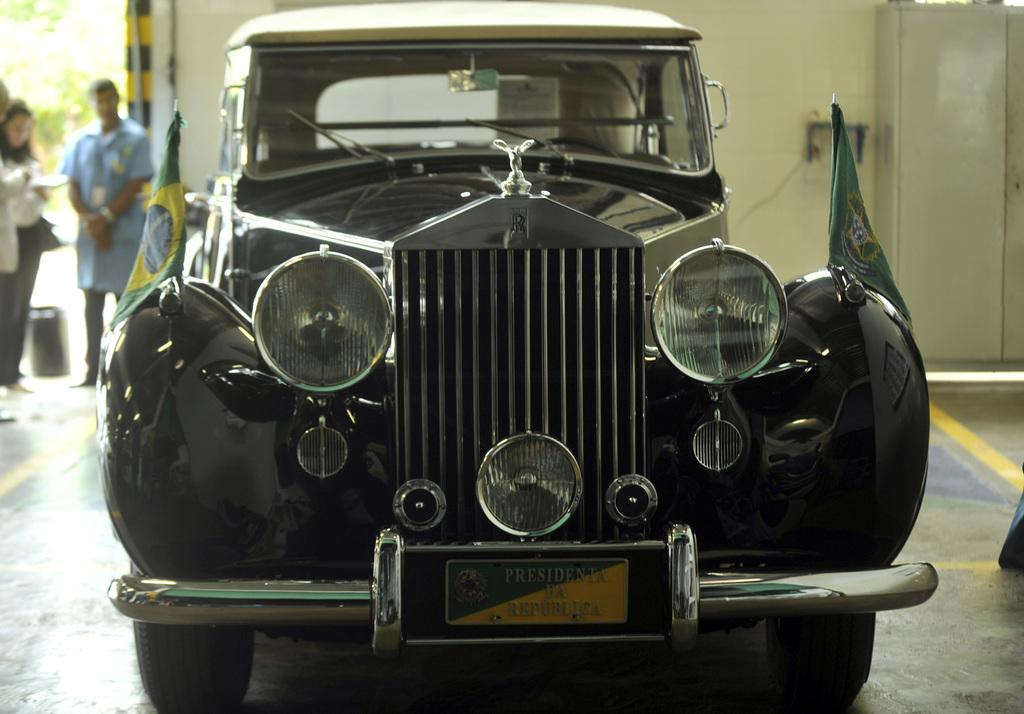What is located on the floor in the foreground of the image? There is a vehicle on the floor in the foreground of the image. Can you describe the people in the background of the image? There are two people standing in the background on the left side. What can be seen in the background of the image? There appears to be a wall in the background of the image. What type of leaf is being used as a chain by the representative in the image? There is no leaf or representative present in the image. 